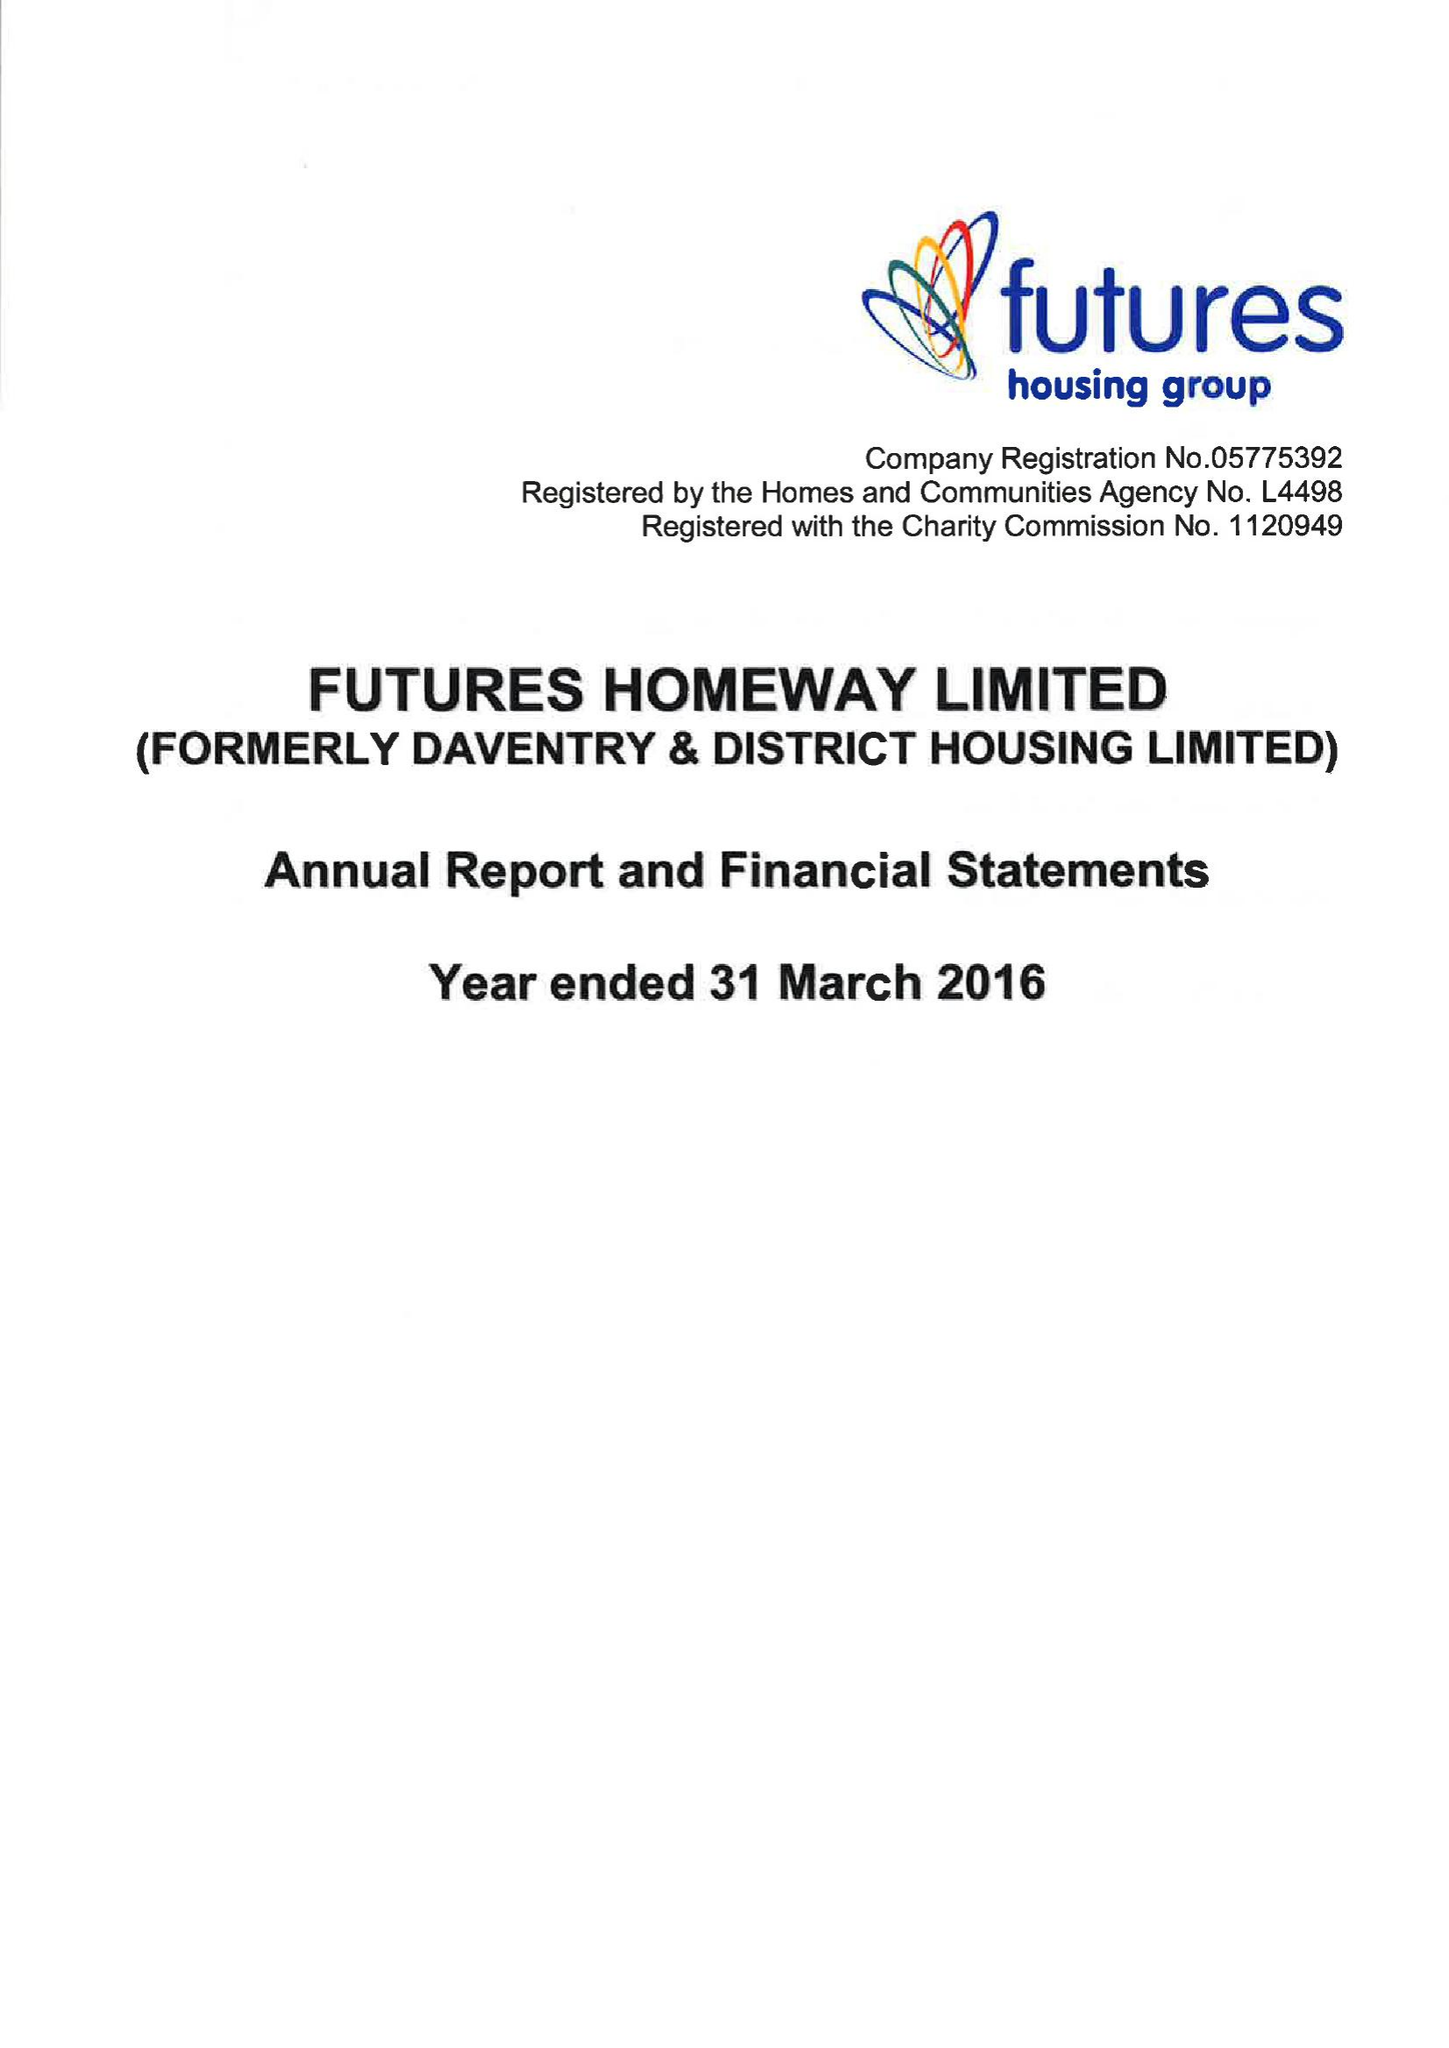What is the value for the charity_name?
Answer the question using a single word or phrase. Futures Homeway Ltd. 